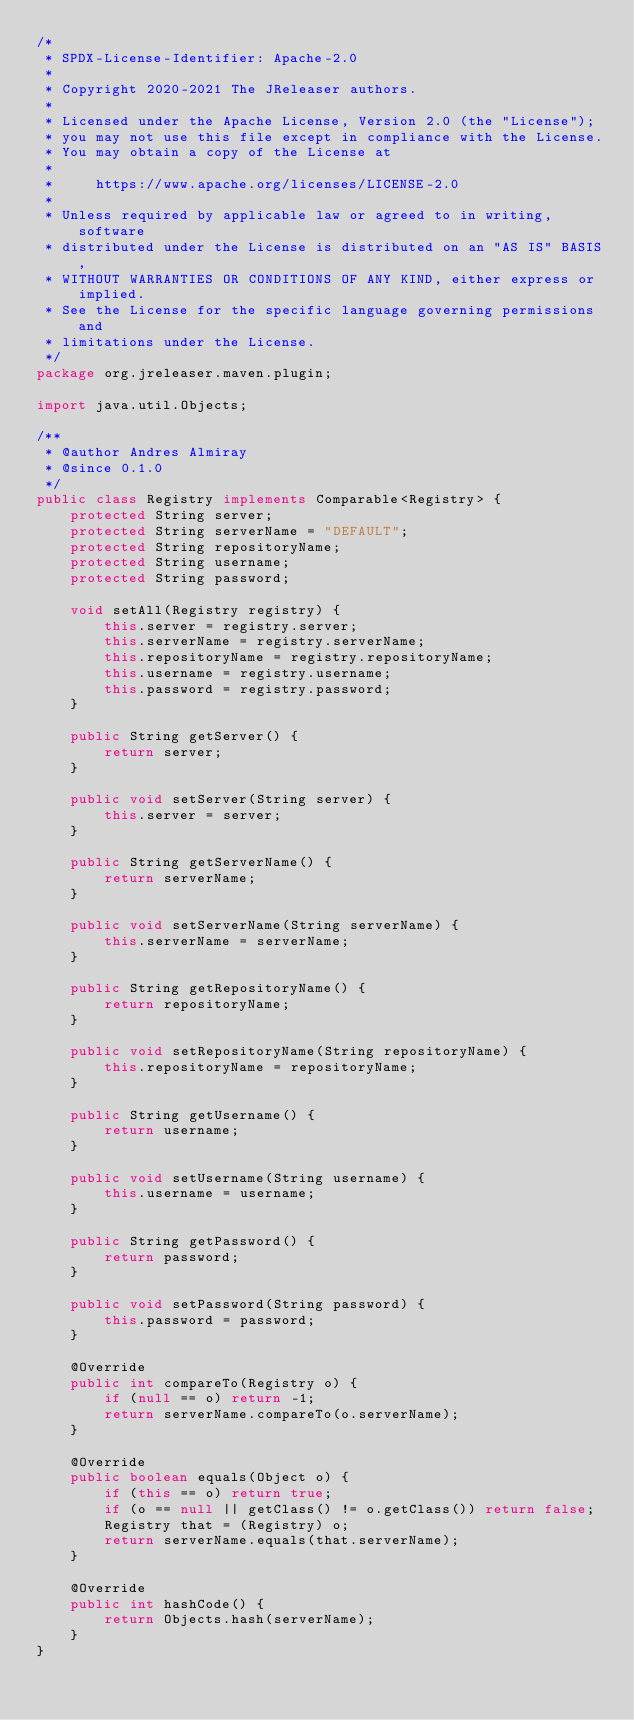<code> <loc_0><loc_0><loc_500><loc_500><_Java_>/*
 * SPDX-License-Identifier: Apache-2.0
 *
 * Copyright 2020-2021 The JReleaser authors.
 *
 * Licensed under the Apache License, Version 2.0 (the "License");
 * you may not use this file except in compliance with the License.
 * You may obtain a copy of the License at
 *
 *     https://www.apache.org/licenses/LICENSE-2.0
 *
 * Unless required by applicable law or agreed to in writing, software
 * distributed under the License is distributed on an "AS IS" BASIS,
 * WITHOUT WARRANTIES OR CONDITIONS OF ANY KIND, either express or implied.
 * See the License for the specific language governing permissions and
 * limitations under the License.
 */
package org.jreleaser.maven.plugin;

import java.util.Objects;

/**
 * @author Andres Almiray
 * @since 0.1.0
 */
public class Registry implements Comparable<Registry> {
    protected String server;
    protected String serverName = "DEFAULT";
    protected String repositoryName;
    protected String username;
    protected String password;

    void setAll(Registry registry) {
        this.server = registry.server;
        this.serverName = registry.serverName;
        this.repositoryName = registry.repositoryName;
        this.username = registry.username;
        this.password = registry.password;
    }

    public String getServer() {
        return server;
    }

    public void setServer(String server) {
        this.server = server;
    }

    public String getServerName() {
        return serverName;
    }

    public void setServerName(String serverName) {
        this.serverName = serverName;
    }

    public String getRepositoryName() {
        return repositoryName;
    }

    public void setRepositoryName(String repositoryName) {
        this.repositoryName = repositoryName;
    }

    public String getUsername() {
        return username;
    }

    public void setUsername(String username) {
        this.username = username;
    }

    public String getPassword() {
        return password;
    }

    public void setPassword(String password) {
        this.password = password;
    }

    @Override
    public int compareTo(Registry o) {
        if (null == o) return -1;
        return serverName.compareTo(o.serverName);
    }

    @Override
    public boolean equals(Object o) {
        if (this == o) return true;
        if (o == null || getClass() != o.getClass()) return false;
        Registry that = (Registry) o;
        return serverName.equals(that.serverName);
    }

    @Override
    public int hashCode() {
        return Objects.hash(serverName);
    }
}
</code> 